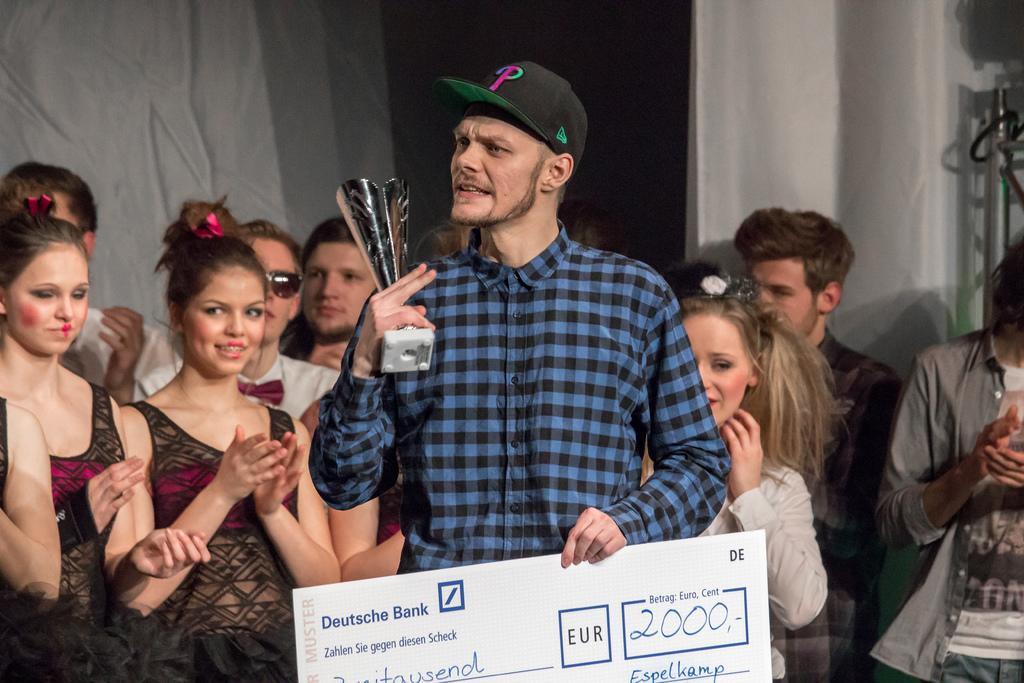Describe this image in one or two sentences. In this image we can see a person wearing blue color dress holding award in his hands and check and at the background of the image there are some group of persons standing. 